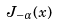<formula> <loc_0><loc_0><loc_500><loc_500>J _ { - \alpha } ( x )</formula> 